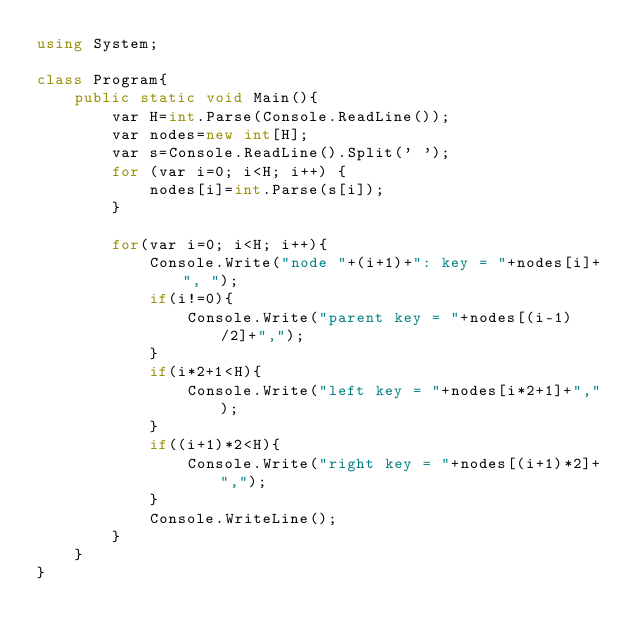<code> <loc_0><loc_0><loc_500><loc_500><_C#_>using System;

class Program{
    public static void Main(){
        var H=int.Parse(Console.ReadLine());
        var nodes=new int[H];
        var s=Console.ReadLine().Split(' ');
        for (var i=0; i<H; i++) {
            nodes[i]=int.Parse(s[i]);
        }

        for(var i=0; i<H; i++){
            Console.Write("node "+(i+1)+": key = "+nodes[i]+", ");
            if(i!=0){
                Console.Write("parent key = "+nodes[(i-1)/2]+",");
            }
            if(i*2+1<H){
                Console.Write("left key = "+nodes[i*2+1]+",");
            }
            if((i+1)*2<H){
                Console.Write("right key = "+nodes[(i+1)*2]+",");
            }
            Console.WriteLine();
        }
    }
}</code> 